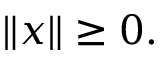<formula> <loc_0><loc_0><loc_500><loc_500>\| x \| \geq 0 .</formula> 